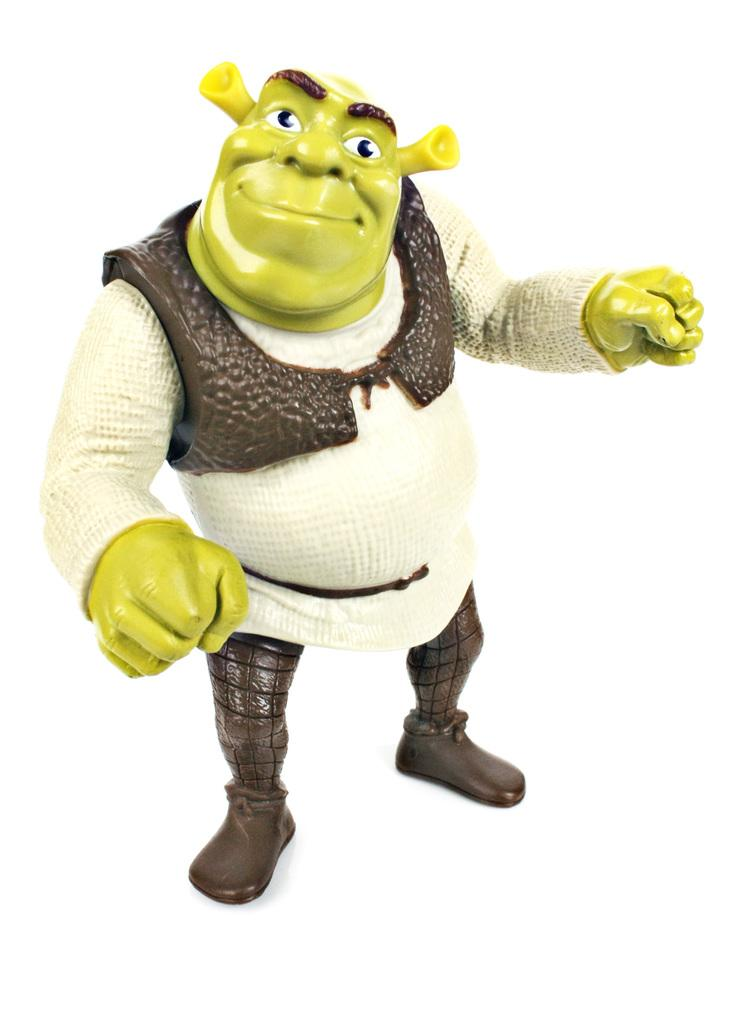What is located in the foreground of the image? There is a soft toy in the foreground of the image. What is the soft toy wearing on its upper body? The soft toy is wearing a white shirt and a brown jacket. What type of footwear is the soft toy wearing? The soft toy is wearing brown shoes. What feature of the soft toy is particularly noticeable? The soft toy has large ears. How does the soft toy help with the digestion process in the image? The soft toy does not have any role in the digestion process, as it is an inanimate object and not a living being. 